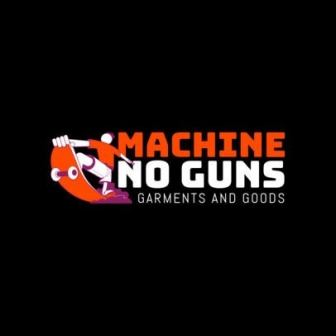What do you think is going on in this snapshot? This image features a logo for a company called 'Machine No Guns' that specializes in garments and goods. The logo is set against a black background, creating a vivid contrast. The central design features a cartoon character holding a machine gun, with a red circle and a slash over the gun—an unmistakable symbol indicating prohibition. Surrounding this central design, the company's name is prominently displayed in bold orange and white letters. Below the logo, in smaller white text, is the description 'Garments and Goods,' indicating the company's offerings. The overall layout is designed to draw attention to the central message—promoting the company's anti-gun stance and showcasing their brand identity. 